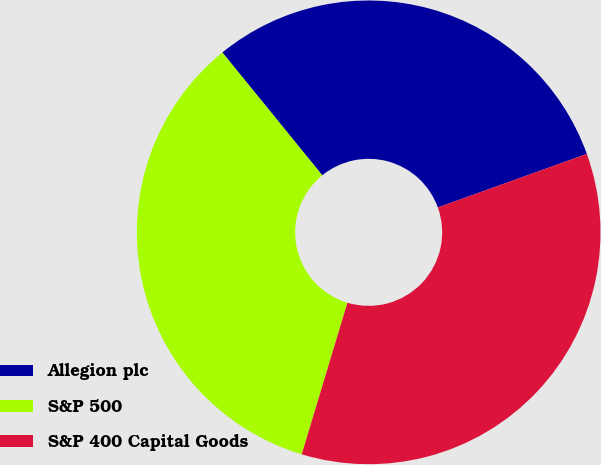Convert chart. <chart><loc_0><loc_0><loc_500><loc_500><pie_chart><fcel>Allegion plc<fcel>S&P 500<fcel>S&P 400 Capital Goods<nl><fcel>30.38%<fcel>34.47%<fcel>35.15%<nl></chart> 